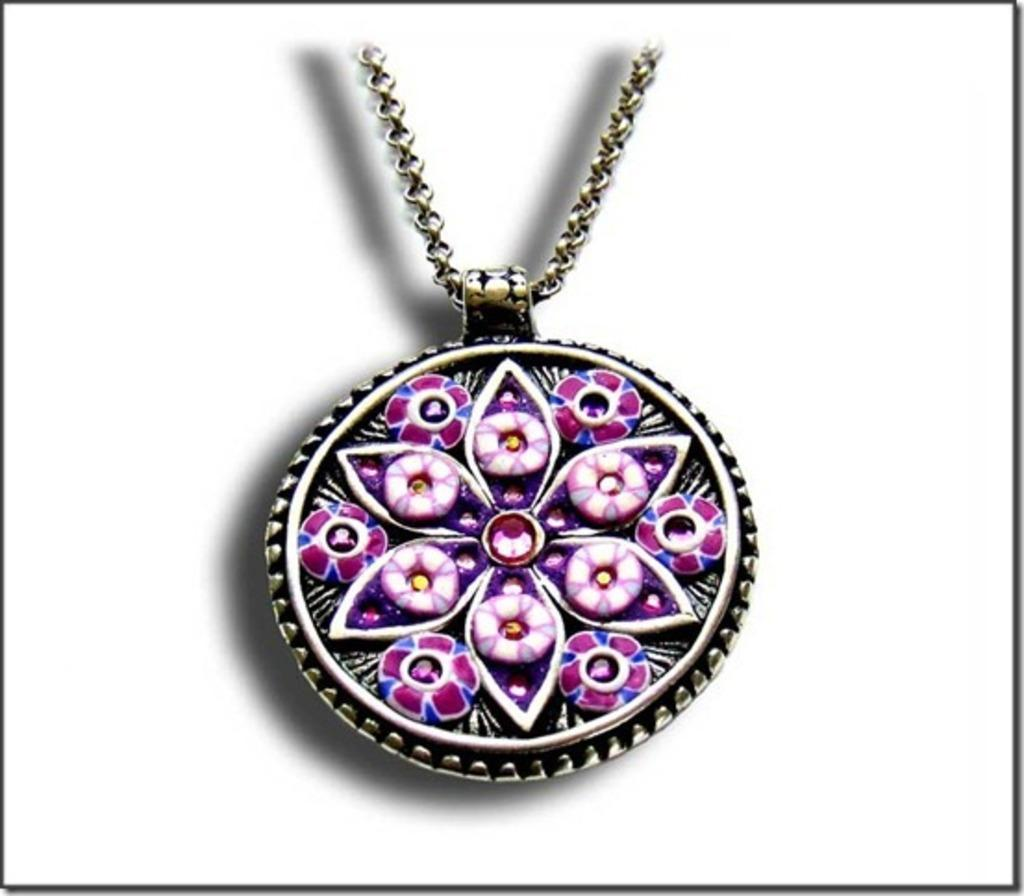What is the main object in the image? There is a locket in the image. What colors are present on the locket? The locket has blue and pink colors. Is there anything attached to the locket? Yes, there is a chain associated with the locket. What is the color of the background in the image? The background of the image is white. What type of joke is written on the locket in the image? There is no joke written on the locket in the image; it only has blue and pink colors. How much paste is needed to attach the locket to the background? There is no paste present in the image, as the locket is not attached to the background. 